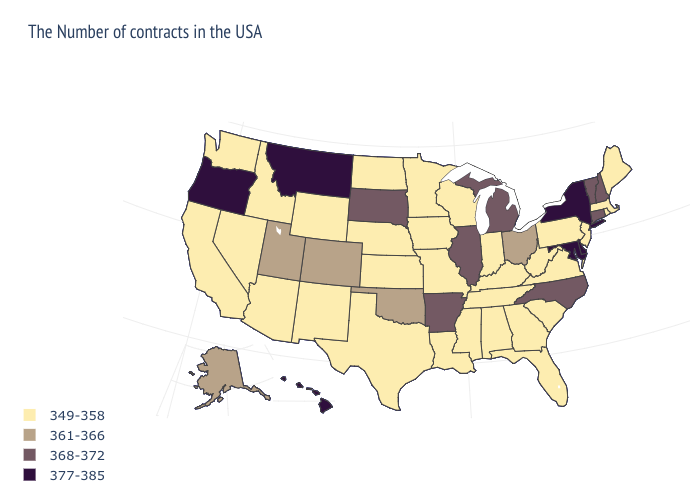Which states hav the highest value in the West?
Give a very brief answer. Montana, Oregon, Hawaii. Does the first symbol in the legend represent the smallest category?
Concise answer only. Yes. Does the map have missing data?
Quick response, please. No. Among the states that border Idaho , does Nevada have the lowest value?
Write a very short answer. Yes. What is the value of South Carolina?
Short answer required. 349-358. Does Arizona have the highest value in the West?
Give a very brief answer. No. Does West Virginia have the same value as New Hampshire?
Concise answer only. No. Which states have the highest value in the USA?
Keep it brief. New York, Delaware, Maryland, Montana, Oregon, Hawaii. What is the value of Nebraska?
Quick response, please. 349-358. What is the value of Michigan?
Be succinct. 368-372. Name the states that have a value in the range 368-372?
Short answer required. New Hampshire, Vermont, Connecticut, North Carolina, Michigan, Illinois, Arkansas, South Dakota. How many symbols are there in the legend?
Keep it brief. 4. Name the states that have a value in the range 361-366?
Answer briefly. Ohio, Oklahoma, Colorado, Utah, Alaska. Does Wyoming have the highest value in the West?
Be succinct. No. Does the map have missing data?
Answer briefly. No. 